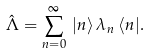<formula> <loc_0><loc_0><loc_500><loc_500>\hat { \Lambda } = \sum _ { n = 0 } ^ { \infty } \, | n \rangle \, \lambda _ { n } \, \langle n | .</formula> 